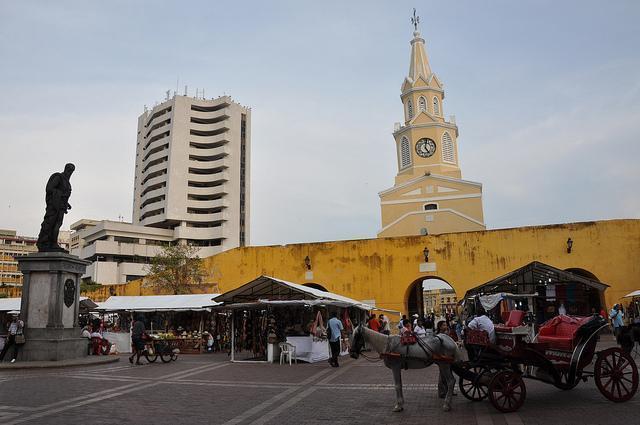Which structure was put up most recently?
Choose the right answer and clarify with the format: 'Answer: answer
Rationale: rationale.'
Options: High rise, tent, clock tower, statue. Answer: tent.
Rationale: A tent was likely put up most recently. 